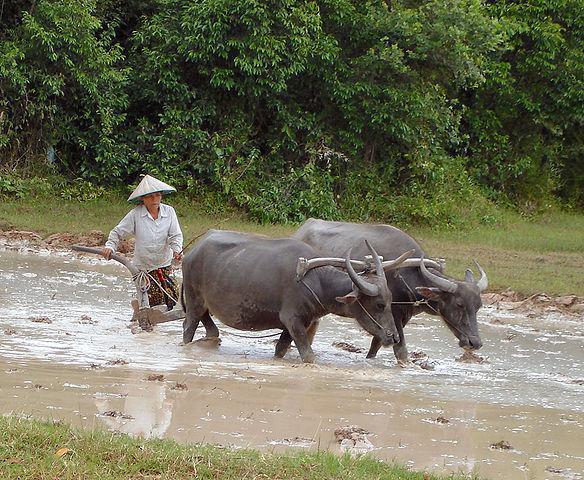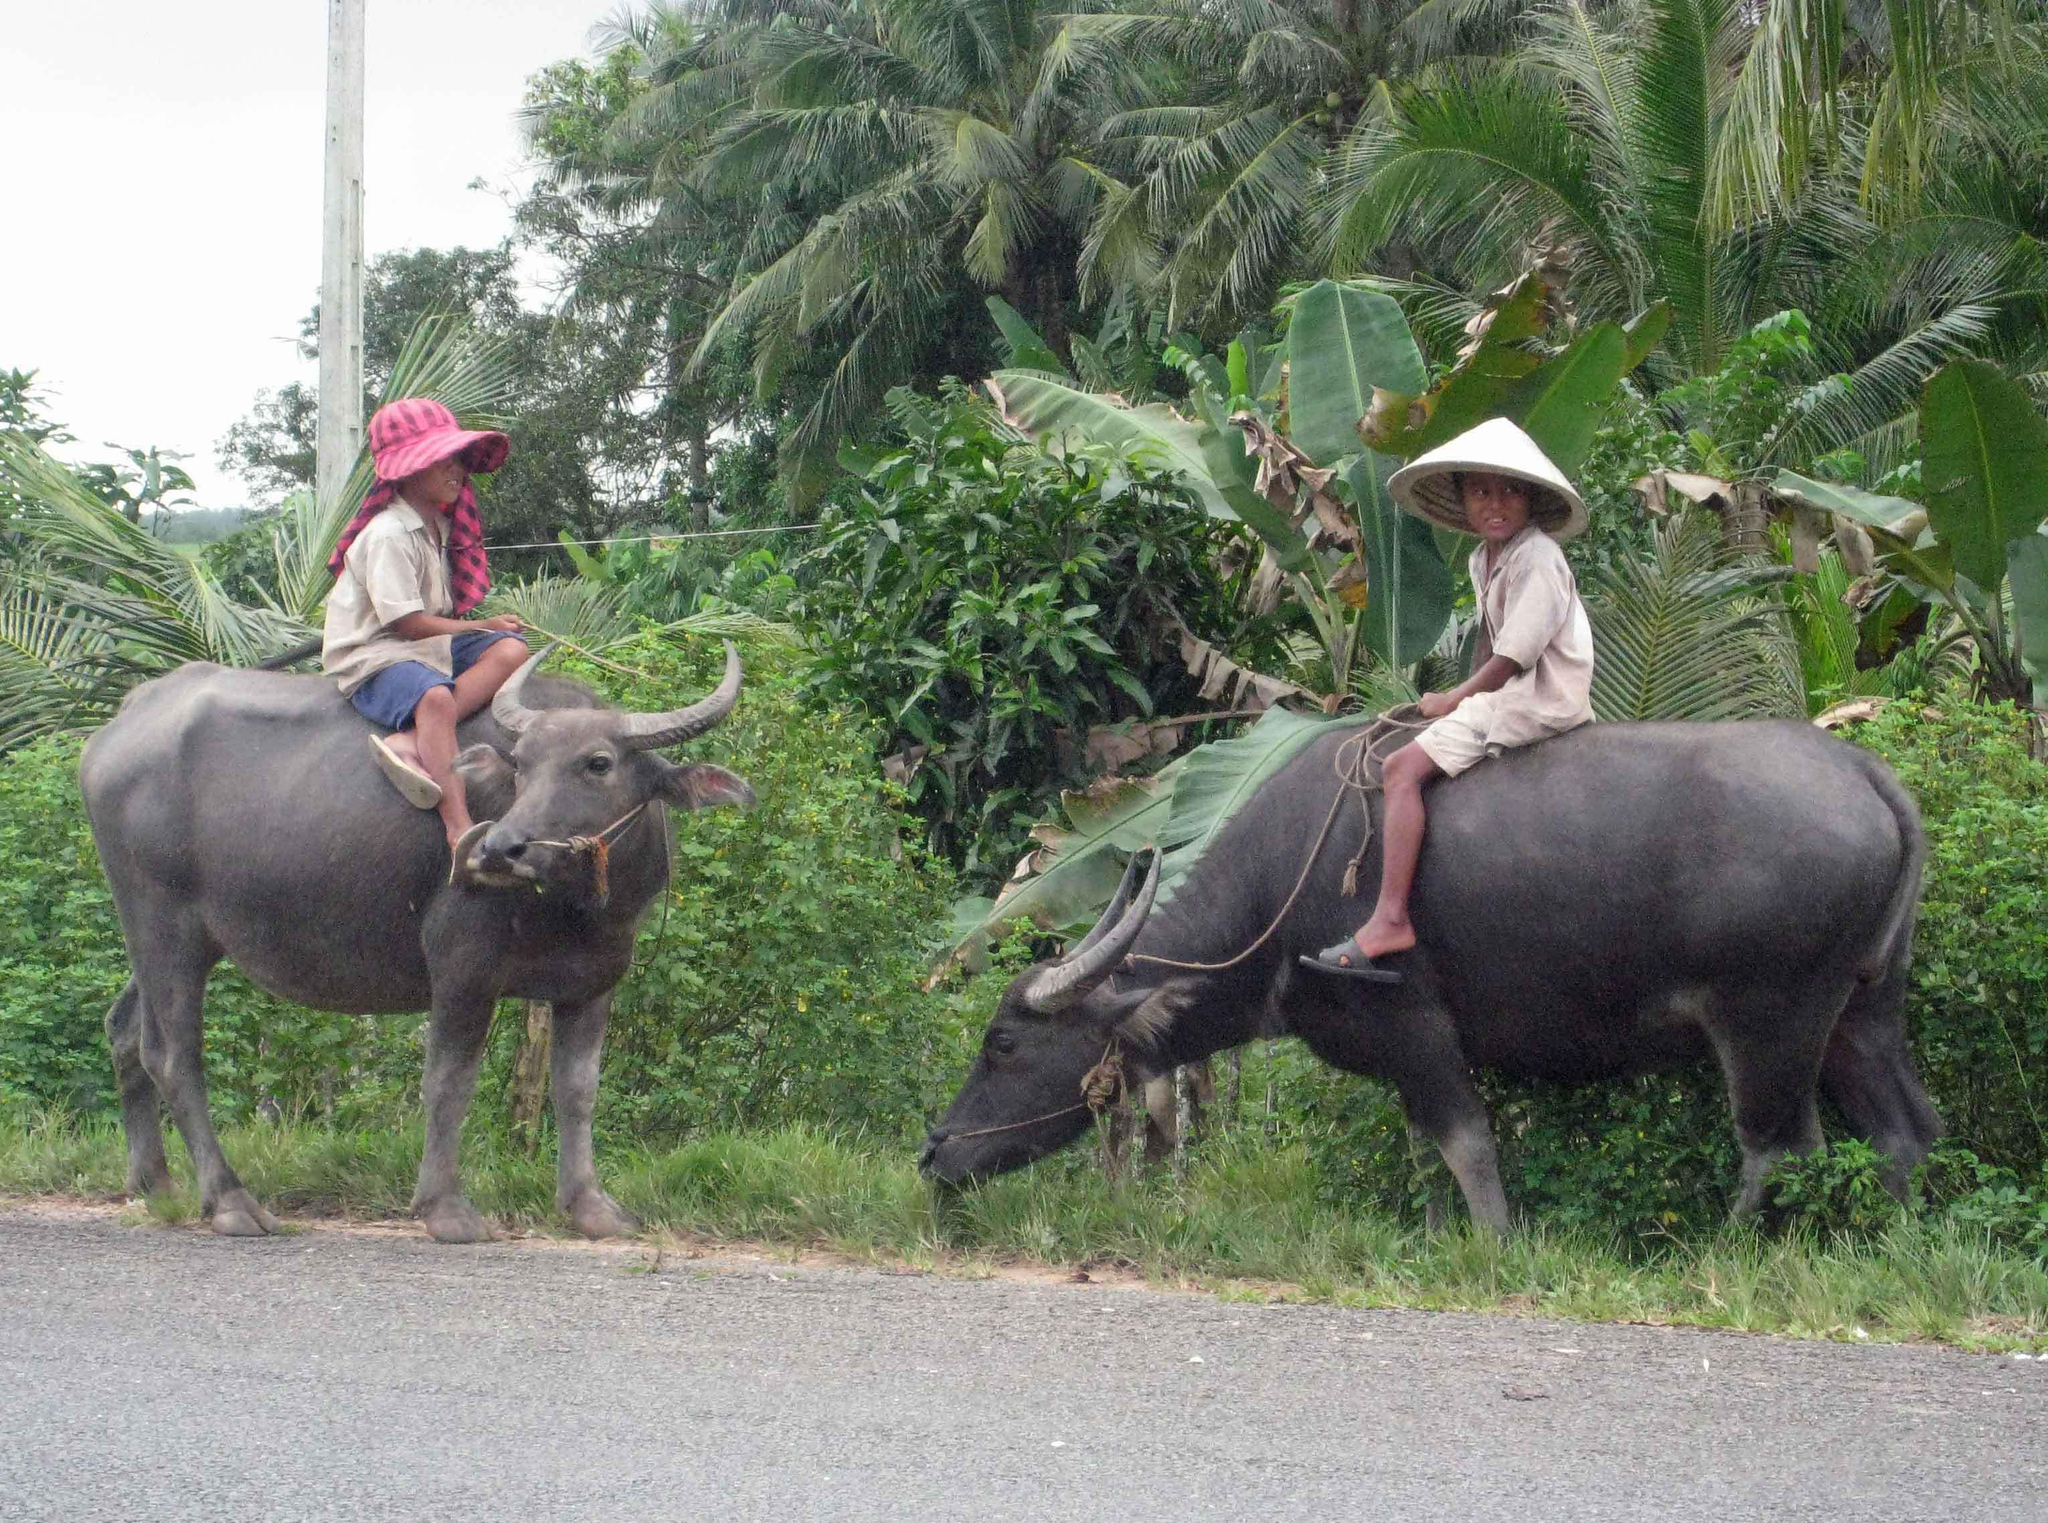The first image is the image on the left, the second image is the image on the right. For the images displayed, is the sentence "The left image shows one adult in a hat holding a stick behind a team of two hitched oxen walking in a wet area." factually correct? Answer yes or no. Yes. The first image is the image on the left, the second image is the image on the right. Assess this claim about the two images: "There are exactly two water buffalo in the left image.". Correct or not? Answer yes or no. Yes. 